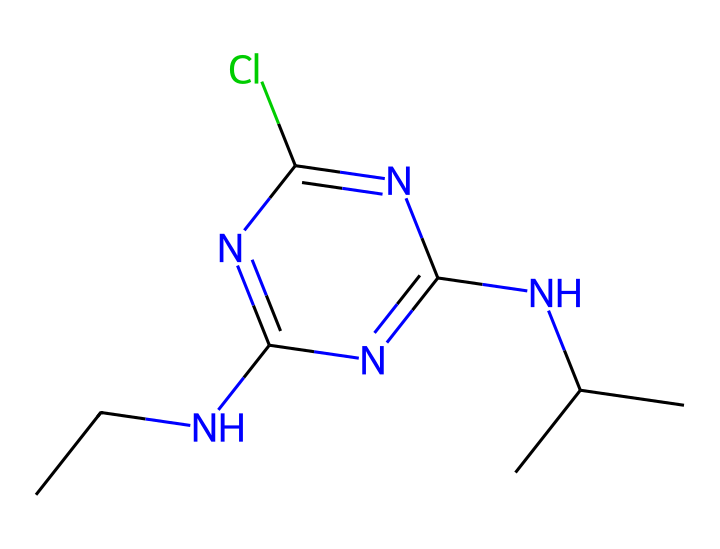What is the molecular formula of atrazine? To determine the molecular formula, we count the number of each type of atom in the SMILES representation. The breakdown yields 12 carbon (C) atoms, 14 hydrogen (H) atoms, 4 nitrogen (N) atoms, and 1 chlorine (Cl) atom. So, the molecular formula is C12H14ClN5.
Answer: C12H14ClN5 How many nitrogen atoms are present in the atrazine structure? By analyzing the SMILES string, we identify five nitrogen (N) atoms appearing in the structural representation. Therefore, the total number of nitrogen atoms is 5.
Answer: 5 What type of chemical is atrazine classified as? Atrazine is an herbicide, which is a type of pesticide specifically designed to kill or control unwanted plants (weeds). The presence of nitrogen and its function in agriculture categorizes it as an herbicide.
Answer: herbicide Does atrazine contain any halogen atoms? In reviewing the molecular structure, we see one chlorine (Cl) atom, which is classified as a halogen. Therefore, atrazine does contain halogen atoms.
Answer: yes What functional group is present in the atrazine molecule? The molecule contains an amine functional group, indicated by the presence of nitrogen atoms bonded to carbon or hydrogen atoms. Specifically, the presence of -NH- groups classifies them as amines.
Answer: amine What is the significance of the chlorine atom in atrazine? The chlorine atom in atrazine plays a role in enhancing its herbicidal properties by increasing the compound’s lipophilicity, aiding in its penetration through plant membranes and contributing to its overall effectiveness.
Answer: enhance herbicidal properties 